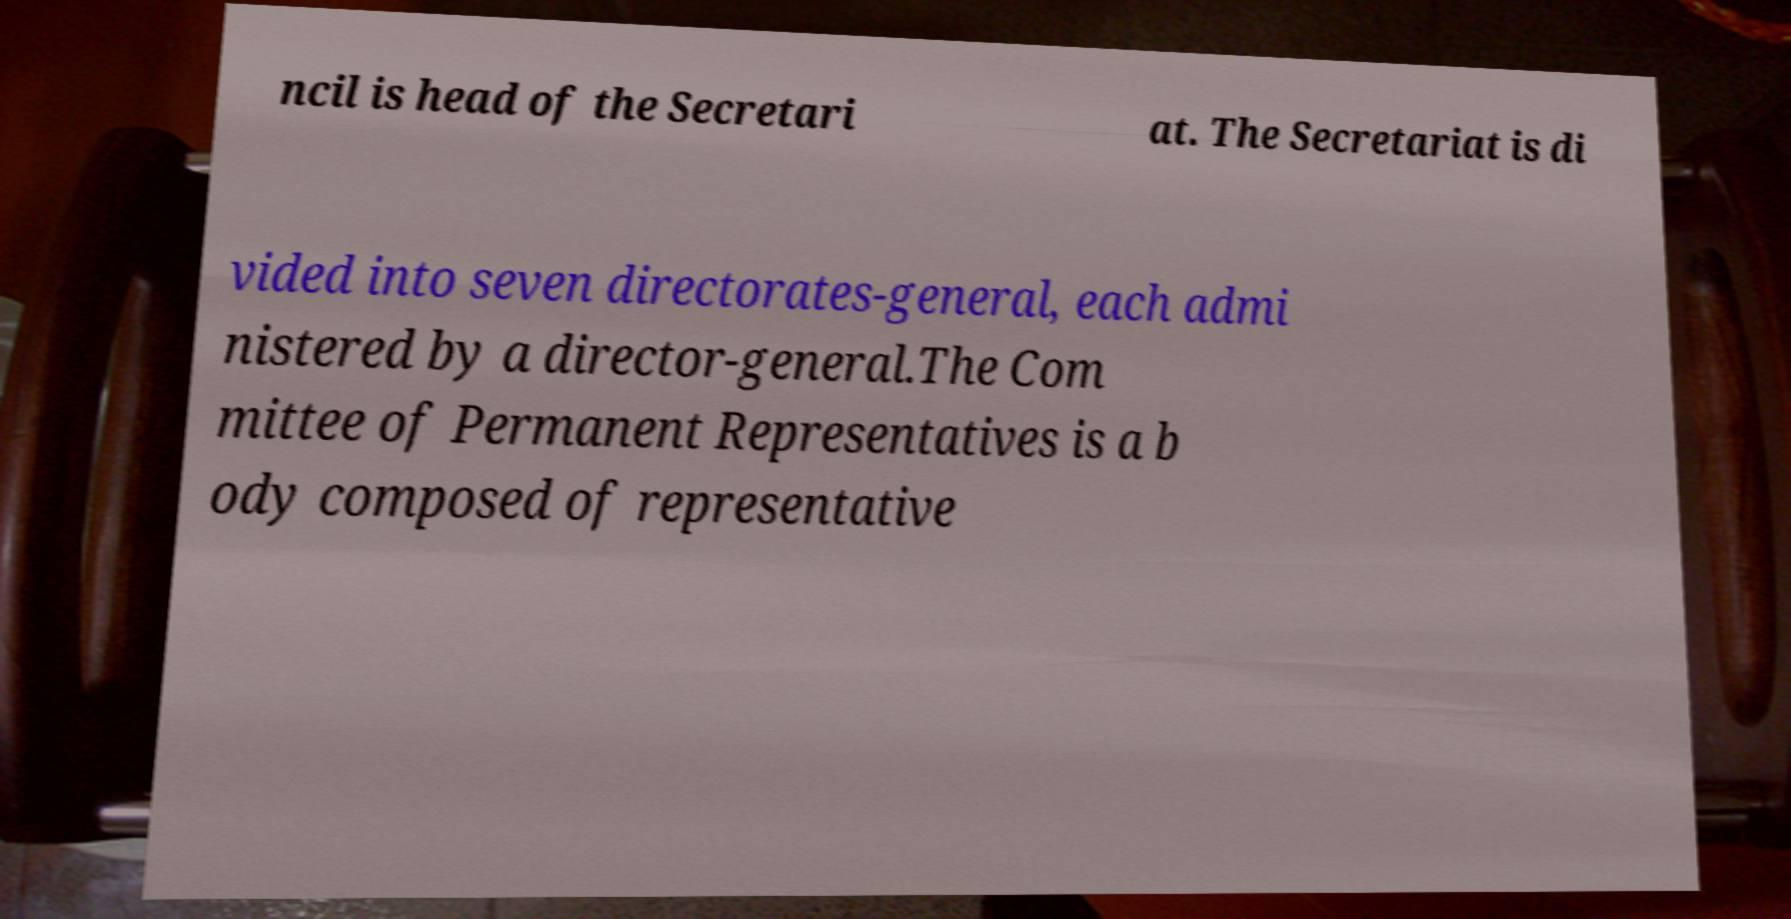Can you accurately transcribe the text from the provided image for me? ncil is head of the Secretari at. The Secretariat is di vided into seven directorates-general, each admi nistered by a director-general.The Com mittee of Permanent Representatives is a b ody composed of representative 